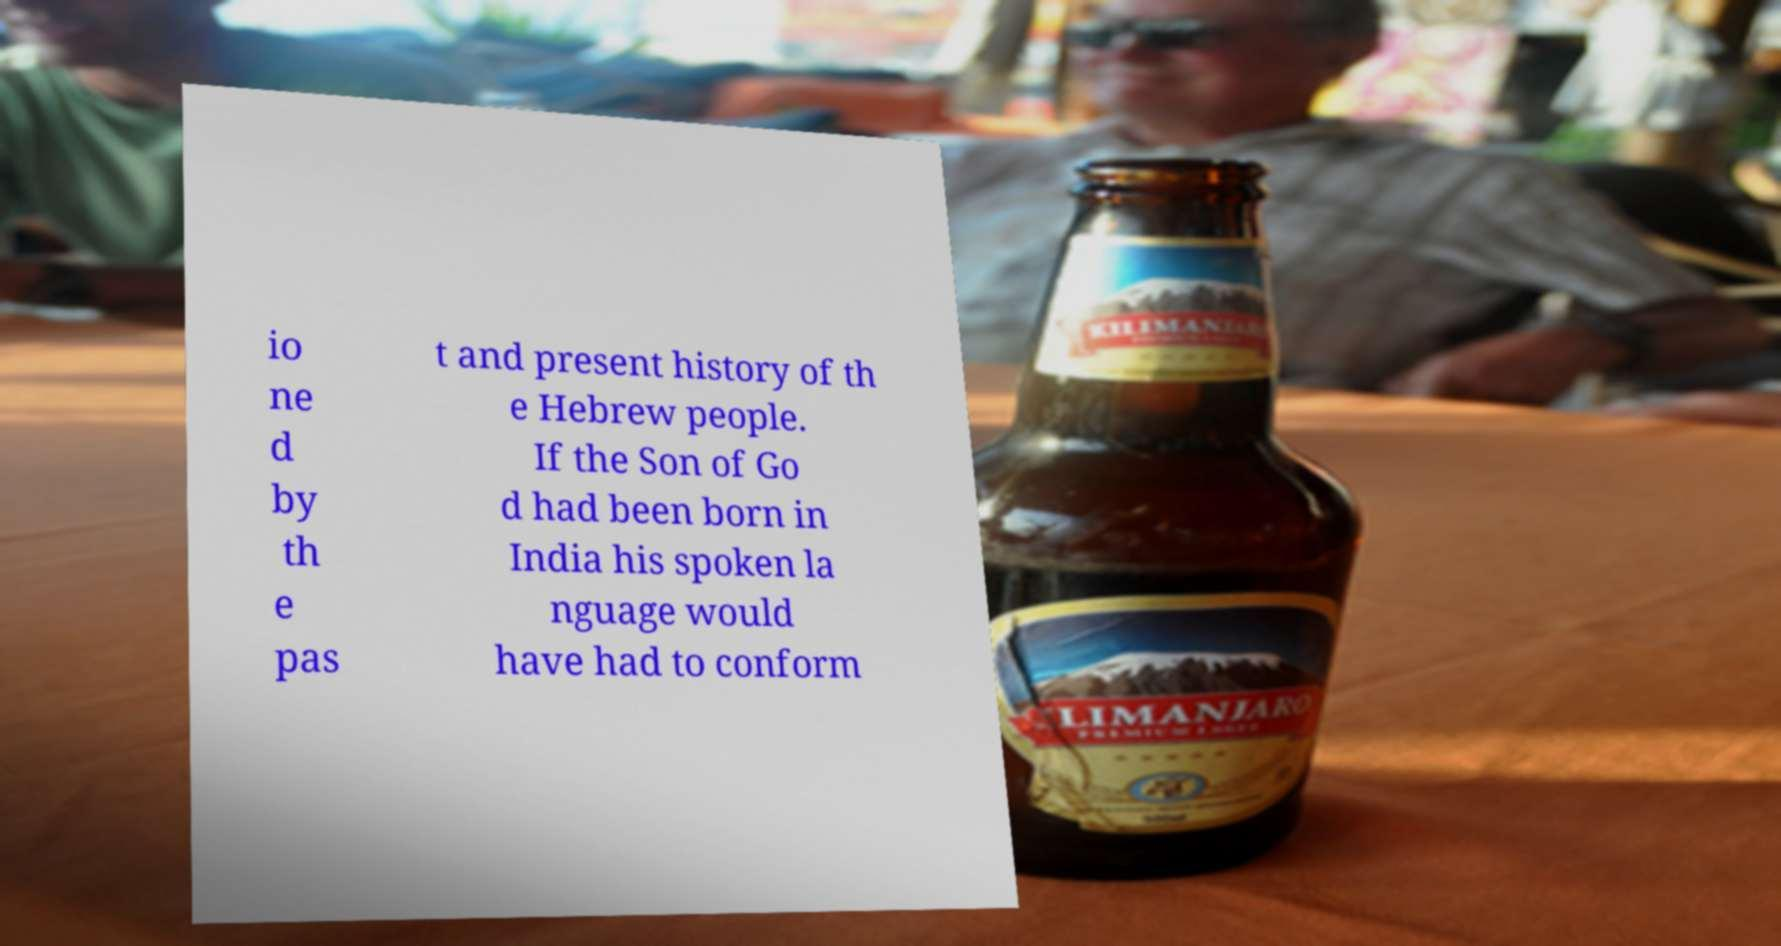Please read and relay the text visible in this image. What does it say? io ne d by th e pas t and present history of th e Hebrew people. If the Son of Go d had been born in India his spoken la nguage would have had to conform 